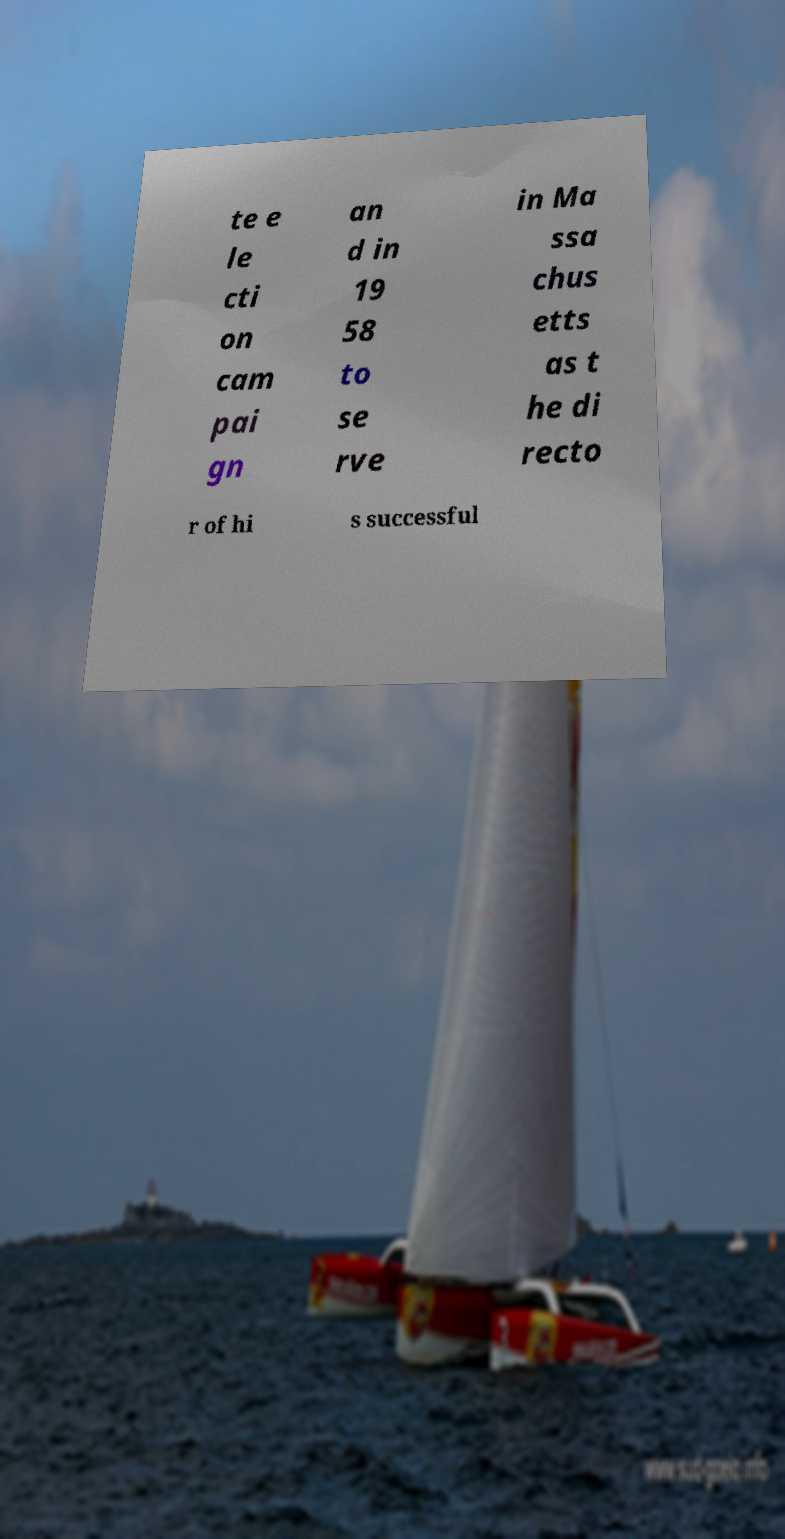I need the written content from this picture converted into text. Can you do that? te e le cti on cam pai gn an d in 19 58 to se rve in Ma ssa chus etts as t he di recto r of hi s successful 